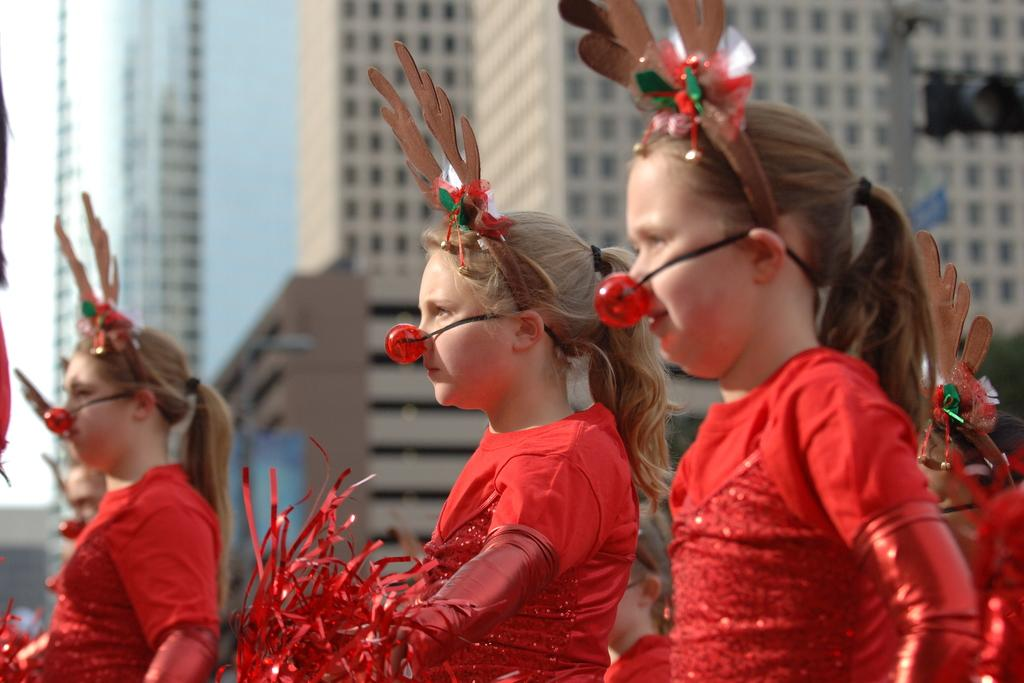Who is present in the image? There are girls in the image. What are the girls wearing? The girls are wearing red-colored dresses. What else can be seen in the image besides the girls? There are decorative items in the image. What is visible in the background of the image? There are buildings and the sky visible in the background of the image. What tax rate is applied to the decorative items in the image? There is no information about tax rates in the image, as it focuses on the girls and their surroundings. 